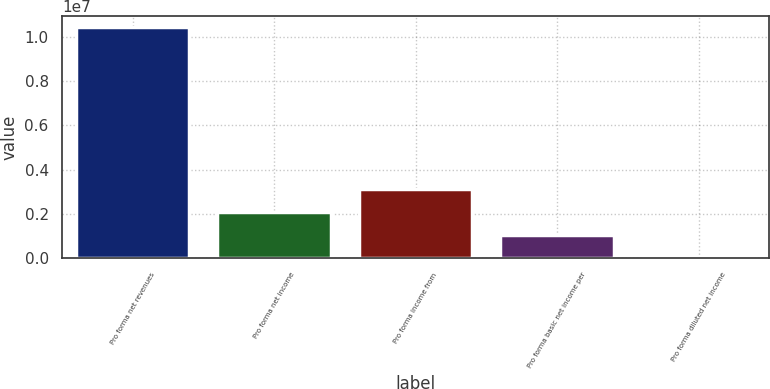<chart> <loc_0><loc_0><loc_500><loc_500><bar_chart><fcel>Pro forma net revenues<fcel>Pro forma net income<fcel>Pro forma income from<fcel>Pro forma basic net income per<fcel>Pro forma diluted net income<nl><fcel>1.04201e+07<fcel>2.08402e+06<fcel>3.12603e+06<fcel>1.04201e+06<fcel>8.48<nl></chart> 